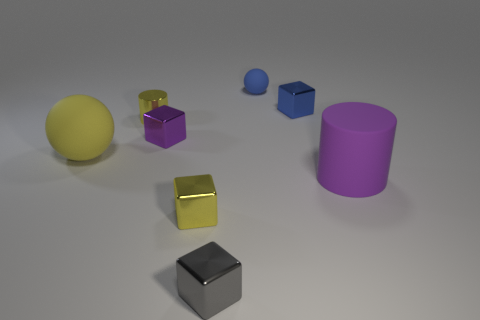Subtract all blue metal cubes. How many cubes are left? 3 Add 1 cyan rubber balls. How many objects exist? 9 Subtract all blue cubes. How many cubes are left? 3 Subtract all spheres. How many objects are left? 6 Subtract all gray cubes. Subtract all small balls. How many objects are left? 6 Add 2 purple rubber cylinders. How many purple rubber cylinders are left? 3 Add 5 small blue cubes. How many small blue cubes exist? 6 Subtract 0 red blocks. How many objects are left? 8 Subtract all yellow cubes. Subtract all green balls. How many cubes are left? 3 